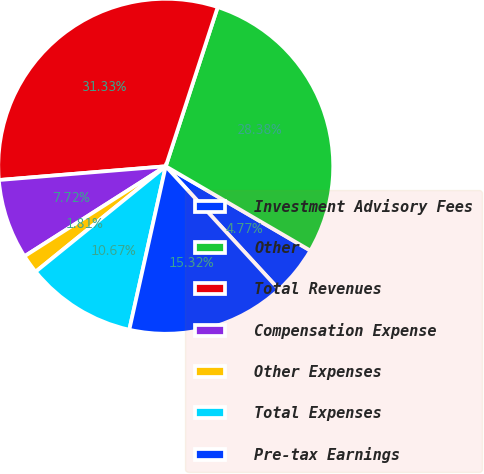Convert chart. <chart><loc_0><loc_0><loc_500><loc_500><pie_chart><fcel>Investment Advisory Fees<fcel>Other<fcel>Total Revenues<fcel>Compensation Expense<fcel>Other Expenses<fcel>Total Expenses<fcel>Pre-tax Earnings<nl><fcel>4.77%<fcel>28.38%<fcel>31.33%<fcel>7.72%<fcel>1.81%<fcel>10.67%<fcel>15.32%<nl></chart> 